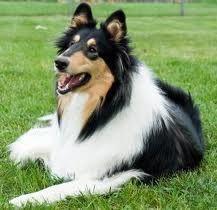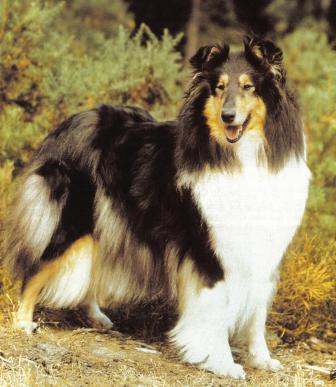The first image is the image on the left, the second image is the image on the right. Given the left and right images, does the statement "One image depicts exactly three collies standing in a row, each with a different fur coloring pattern." hold true? Answer yes or no. No. The first image is the image on the left, the second image is the image on the right. Examine the images to the left and right. Is the description "There are 4 dogs total" accurate? Answer yes or no. No. 